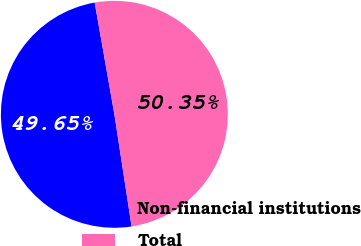Convert chart. <chart><loc_0><loc_0><loc_500><loc_500><pie_chart><fcel>Non-financial institutions<fcel>Total<nl><fcel>49.65%<fcel>50.35%<nl></chart> 